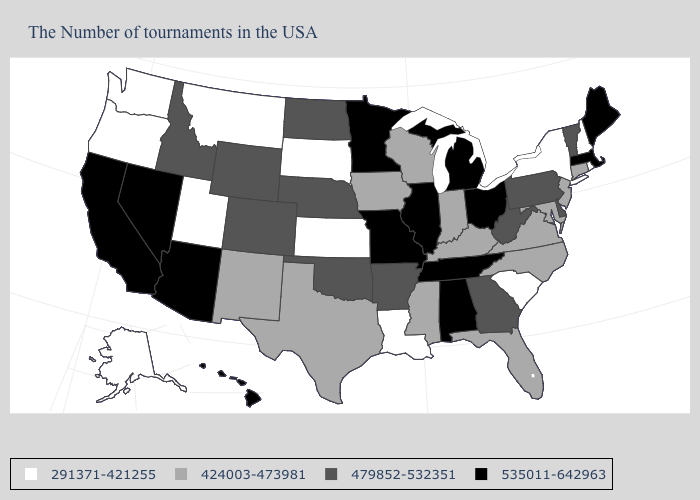What is the value of Maine?
Write a very short answer. 535011-642963. Among the states that border West Virginia , does Kentucky have the lowest value?
Answer briefly. Yes. Among the states that border Ohio , which have the highest value?
Short answer required. Michigan. Does New Jersey have the highest value in the USA?
Give a very brief answer. No. Name the states that have a value in the range 424003-473981?
Answer briefly. Connecticut, New Jersey, Maryland, Virginia, North Carolina, Florida, Kentucky, Indiana, Wisconsin, Mississippi, Iowa, Texas, New Mexico. What is the value of Hawaii?
Keep it brief. 535011-642963. Name the states that have a value in the range 291371-421255?
Quick response, please. Rhode Island, New Hampshire, New York, South Carolina, Louisiana, Kansas, South Dakota, Utah, Montana, Washington, Oregon, Alaska. Does Wisconsin have the same value as Florida?
Give a very brief answer. Yes. What is the value of Maine?
Short answer required. 535011-642963. What is the lowest value in the West?
Quick response, please. 291371-421255. Name the states that have a value in the range 424003-473981?
Concise answer only. Connecticut, New Jersey, Maryland, Virginia, North Carolina, Florida, Kentucky, Indiana, Wisconsin, Mississippi, Iowa, Texas, New Mexico. Name the states that have a value in the range 291371-421255?
Give a very brief answer. Rhode Island, New Hampshire, New York, South Carolina, Louisiana, Kansas, South Dakota, Utah, Montana, Washington, Oregon, Alaska. What is the highest value in the Northeast ?
Give a very brief answer. 535011-642963. What is the value of Nevada?
Write a very short answer. 535011-642963. Does Mississippi have a lower value than Wisconsin?
Quick response, please. No. 